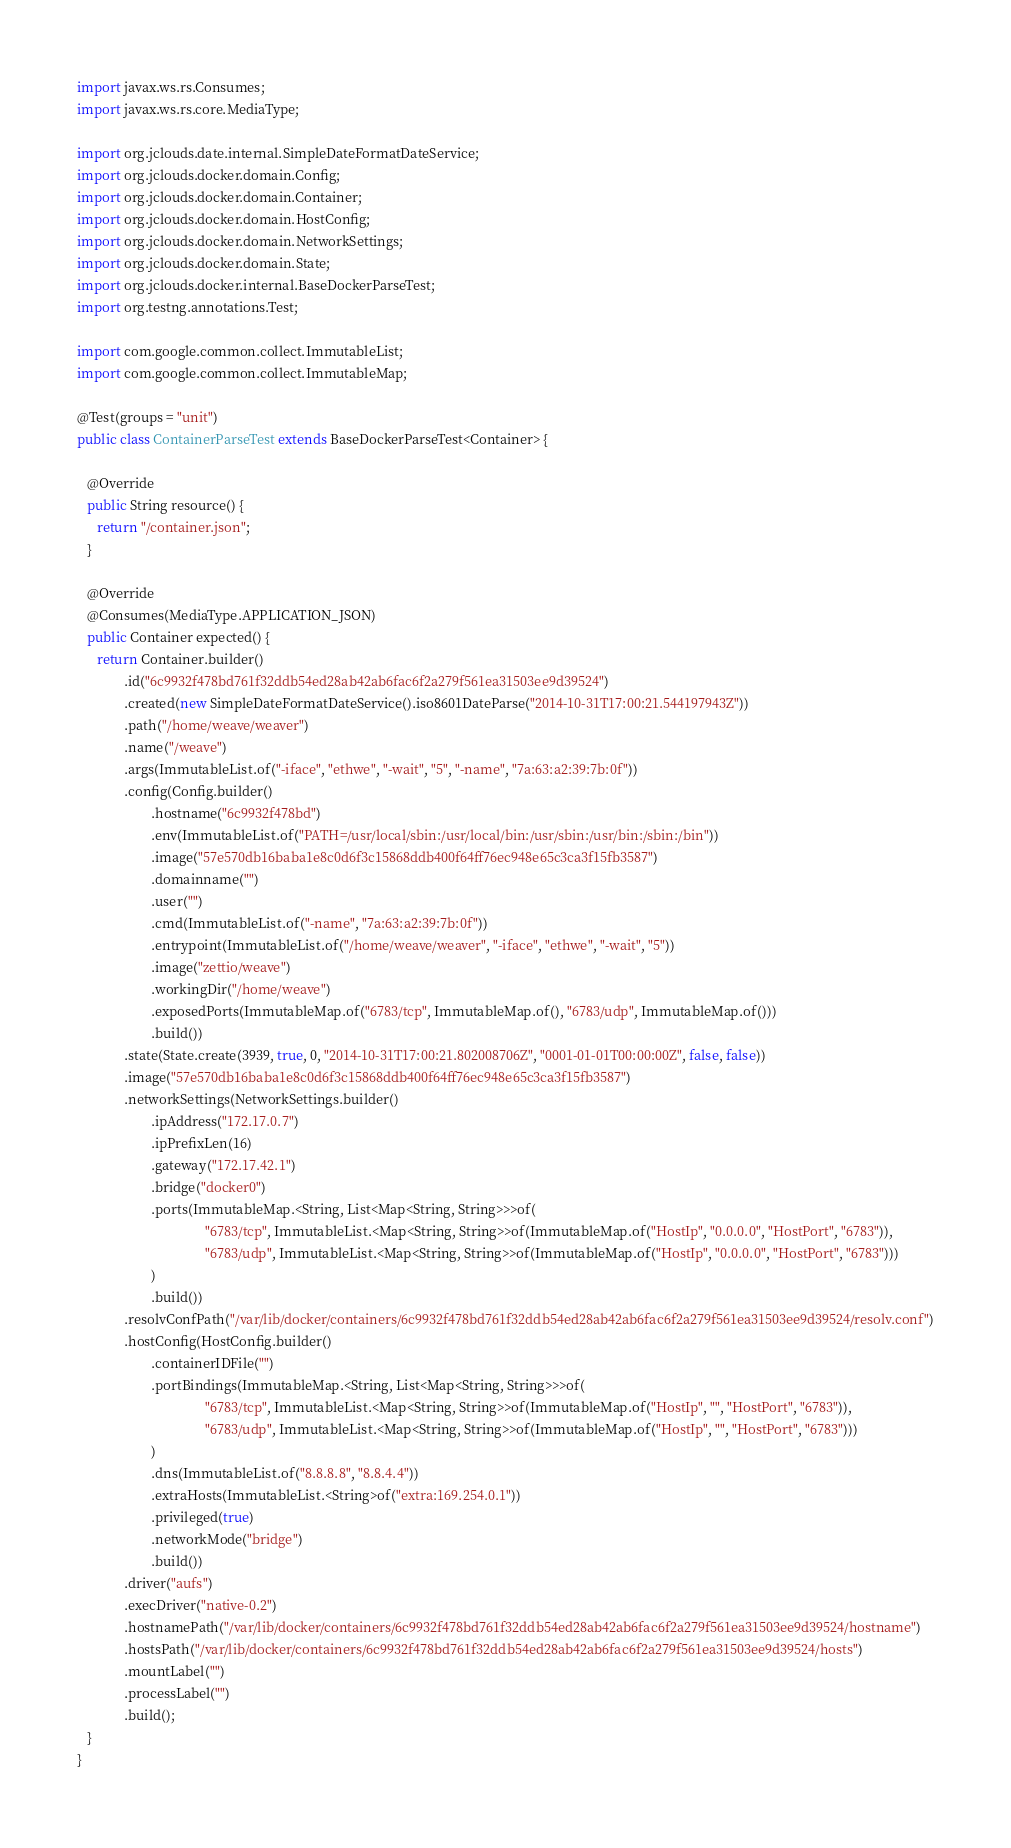Convert code to text. <code><loc_0><loc_0><loc_500><loc_500><_Java_>
import javax.ws.rs.Consumes;
import javax.ws.rs.core.MediaType;

import org.jclouds.date.internal.SimpleDateFormatDateService;
import org.jclouds.docker.domain.Config;
import org.jclouds.docker.domain.Container;
import org.jclouds.docker.domain.HostConfig;
import org.jclouds.docker.domain.NetworkSettings;
import org.jclouds.docker.domain.State;
import org.jclouds.docker.internal.BaseDockerParseTest;
import org.testng.annotations.Test;

import com.google.common.collect.ImmutableList;
import com.google.common.collect.ImmutableMap;

@Test(groups = "unit")
public class ContainerParseTest extends BaseDockerParseTest<Container> {

   @Override
   public String resource() {
      return "/container.json";
   }

   @Override
   @Consumes(MediaType.APPLICATION_JSON)
   public Container expected() {
      return Container.builder()
              .id("6c9932f478bd761f32ddb54ed28ab42ab6fac6f2a279f561ea31503ee9d39524")
              .created(new SimpleDateFormatDateService().iso8601DateParse("2014-10-31T17:00:21.544197943Z"))
              .path("/home/weave/weaver")
              .name("/weave")
              .args(ImmutableList.of("-iface", "ethwe", "-wait", "5", "-name", "7a:63:a2:39:7b:0f"))
              .config(Config.builder()
                      .hostname("6c9932f478bd")
                      .env(ImmutableList.of("PATH=/usr/local/sbin:/usr/local/bin:/usr/sbin:/usr/bin:/sbin:/bin"))
                      .image("57e570db16baba1e8c0d6f3c15868ddb400f64ff76ec948e65c3ca3f15fb3587")
                      .domainname("")
                      .user("")
                      .cmd(ImmutableList.of("-name", "7a:63:a2:39:7b:0f"))
                      .entrypoint(ImmutableList.of("/home/weave/weaver", "-iface", "ethwe", "-wait", "5"))
                      .image("zettio/weave")
                      .workingDir("/home/weave")
                      .exposedPorts(ImmutableMap.of("6783/tcp", ImmutableMap.of(), "6783/udp", ImmutableMap.of()))
                      .build())
              .state(State.create(3939, true, 0, "2014-10-31T17:00:21.802008706Z", "0001-01-01T00:00:00Z", false, false))
              .image("57e570db16baba1e8c0d6f3c15868ddb400f64ff76ec948e65c3ca3f15fb3587")
              .networkSettings(NetworkSettings.builder()
                      .ipAddress("172.17.0.7")
                      .ipPrefixLen(16)
                      .gateway("172.17.42.1")
                      .bridge("docker0")
                      .ports(ImmutableMap.<String, List<Map<String, String>>>of(
                                      "6783/tcp", ImmutableList.<Map<String, String>>of(ImmutableMap.of("HostIp", "0.0.0.0", "HostPort", "6783")),
                                      "6783/udp", ImmutableList.<Map<String, String>>of(ImmutableMap.of("HostIp", "0.0.0.0", "HostPort", "6783")))
                      )
                      .build())
              .resolvConfPath("/var/lib/docker/containers/6c9932f478bd761f32ddb54ed28ab42ab6fac6f2a279f561ea31503ee9d39524/resolv.conf")
              .hostConfig(HostConfig.builder()
                      .containerIDFile("")
                      .portBindings(ImmutableMap.<String, List<Map<String, String>>>of(
                                      "6783/tcp", ImmutableList.<Map<String, String>>of(ImmutableMap.of("HostIp", "", "HostPort", "6783")),
                                      "6783/udp", ImmutableList.<Map<String, String>>of(ImmutableMap.of("HostIp", "", "HostPort", "6783")))
                      )
                      .dns(ImmutableList.of("8.8.8.8", "8.8.4.4"))
                      .extraHosts(ImmutableList.<String>of("extra:169.254.0.1"))
                      .privileged(true)
                      .networkMode("bridge")
                      .build())
              .driver("aufs")
              .execDriver("native-0.2")
              .hostnamePath("/var/lib/docker/containers/6c9932f478bd761f32ddb54ed28ab42ab6fac6f2a279f561ea31503ee9d39524/hostname")
              .hostsPath("/var/lib/docker/containers/6c9932f478bd761f32ddb54ed28ab42ab6fac6f2a279f561ea31503ee9d39524/hosts")
              .mountLabel("")
              .processLabel("")
              .build();
   }
}
</code> 